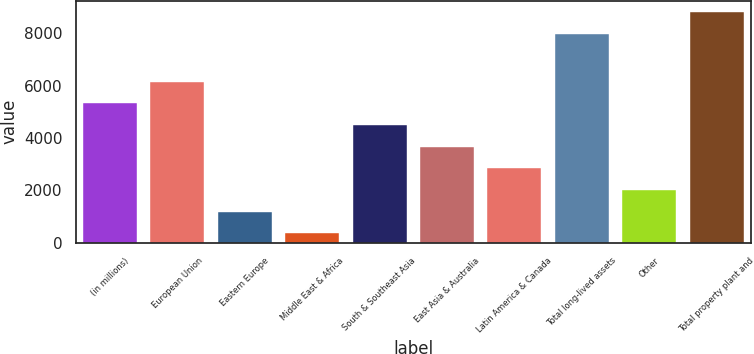Convert chart to OTSL. <chart><loc_0><loc_0><loc_500><loc_500><bar_chart><fcel>(in millions)<fcel>European Union<fcel>Eastern Europe<fcel>Middle East & Africa<fcel>South & Southeast Asia<fcel>East Asia & Australia<fcel>Latin America & Canada<fcel>Total long-lived assets<fcel>Other<fcel>Total property plant and<nl><fcel>5332.4<fcel>6160.8<fcel>1190.4<fcel>362<fcel>4504<fcel>3675.6<fcel>2847.2<fcel>7982<fcel>2018.8<fcel>8810.4<nl></chart> 